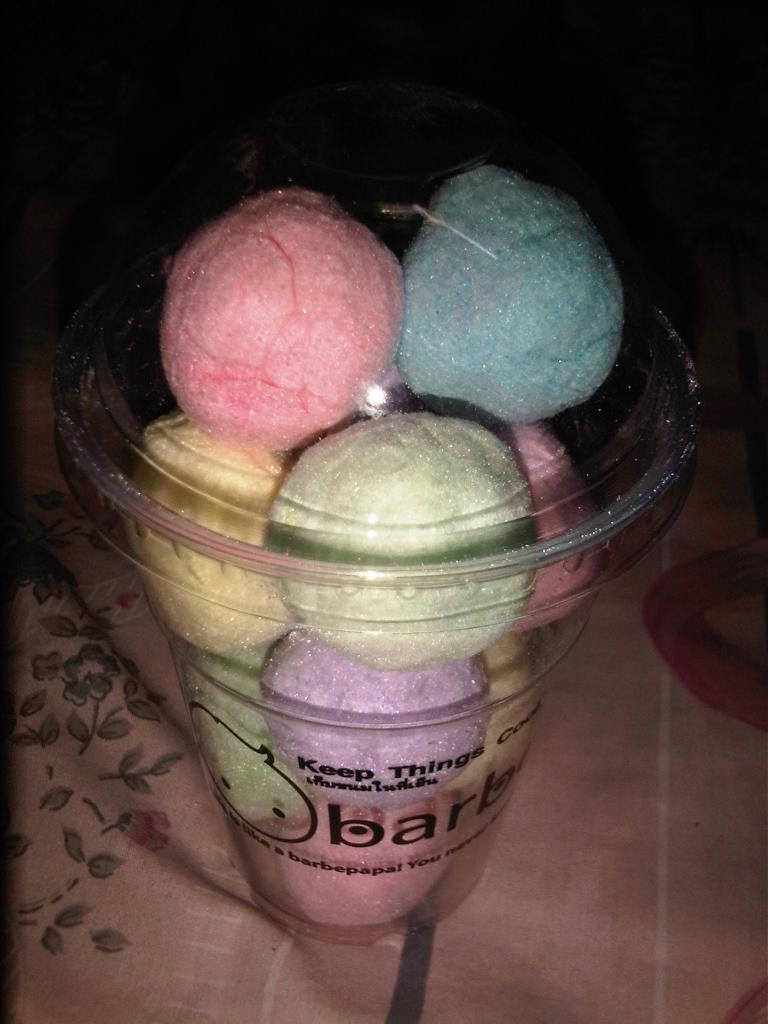What objects are inside the glass in the image? There are different color balls in a glass in the image. What is the glass placed on? The glass is on a cloth. How would you describe the overall lighting in the image? The background of the image is dark. What type of instrument is being played in the image? There is no instrument present in the image; it only features different color balls in a glass on a cloth. 